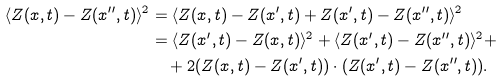<formula> <loc_0><loc_0><loc_500><loc_500>\langle Z ( x , t ) - Z ( x ^ { \prime \prime } , t ) \rangle ^ { 2 } & = \langle Z ( x , t ) - Z ( x ^ { \prime } , t ) + Z ( x ^ { \prime } , t ) - Z ( x ^ { \prime \prime } , t ) \rangle ^ { 2 } \\ & = \langle Z ( x ^ { \prime } , t ) - Z ( x , t ) \rangle ^ { 2 } + \langle Z ( x ^ { \prime } , t ) - Z ( x ^ { \prime \prime } , t ) \rangle ^ { 2 } + \\ & \quad + 2 ( Z ( x , t ) - Z ( x ^ { \prime } , t ) ) \cdot ( Z ( x ^ { \prime } , t ) - Z ( x ^ { \prime \prime } , t ) ) .</formula> 